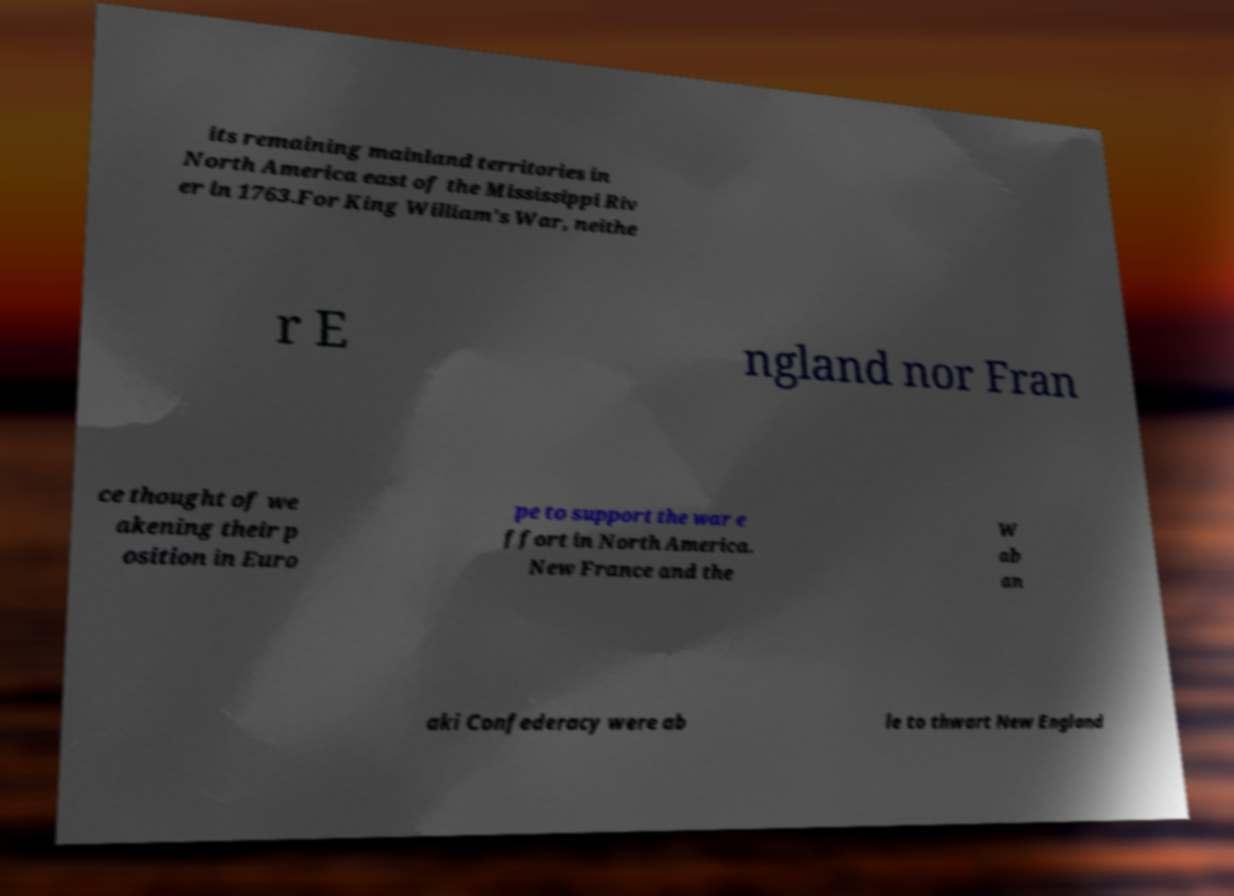Can you read and provide the text displayed in the image?This photo seems to have some interesting text. Can you extract and type it out for me? its remaining mainland territories in North America east of the Mississippi Riv er in 1763.For King William's War, neithe r E ngland nor Fran ce thought of we akening their p osition in Euro pe to support the war e ffort in North America. New France and the W ab an aki Confederacy were ab le to thwart New England 